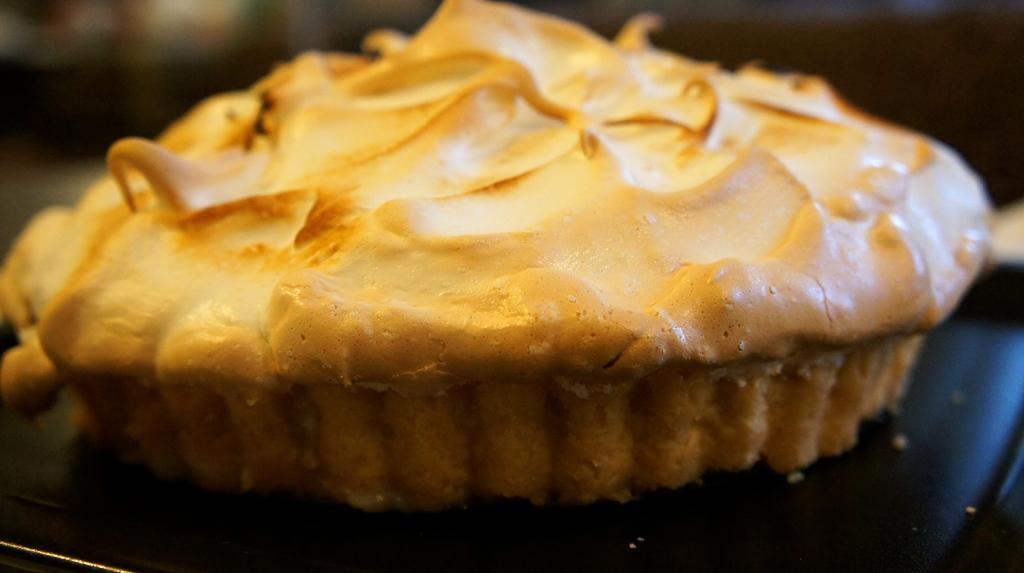Describe this image in one or two sentences. In this picture I can see the cake which is kept on the black plate. In the background I can see the blur image. 